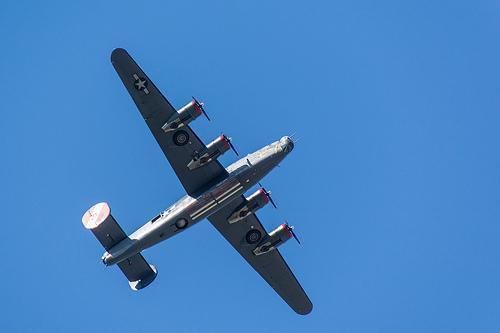How many planes are in the picture?
Give a very brief answer. 1. 